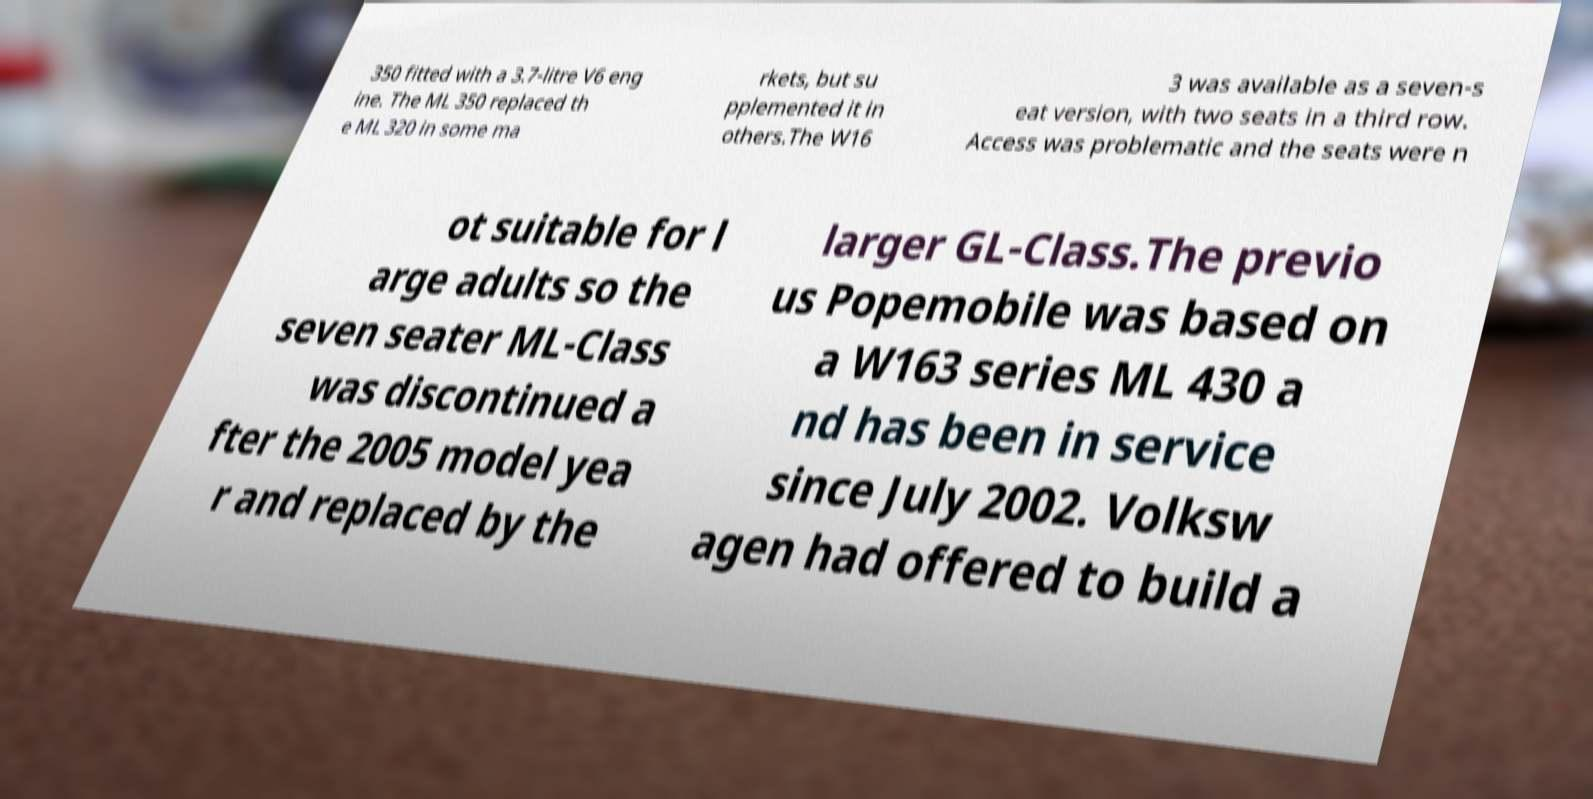I need the written content from this picture converted into text. Can you do that? 350 fitted with a 3.7-litre V6 eng ine. The ML 350 replaced th e ML 320 in some ma rkets, but su pplemented it in others.The W16 3 was available as a seven-s eat version, with two seats in a third row. Access was problematic and the seats were n ot suitable for l arge adults so the seven seater ML-Class was discontinued a fter the 2005 model yea r and replaced by the larger GL-Class.The previo us Popemobile was based on a W163 series ML 430 a nd has been in service since July 2002. Volksw agen had offered to build a 